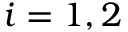Convert formula to latex. <formula><loc_0><loc_0><loc_500><loc_500>i = 1 , 2</formula> 